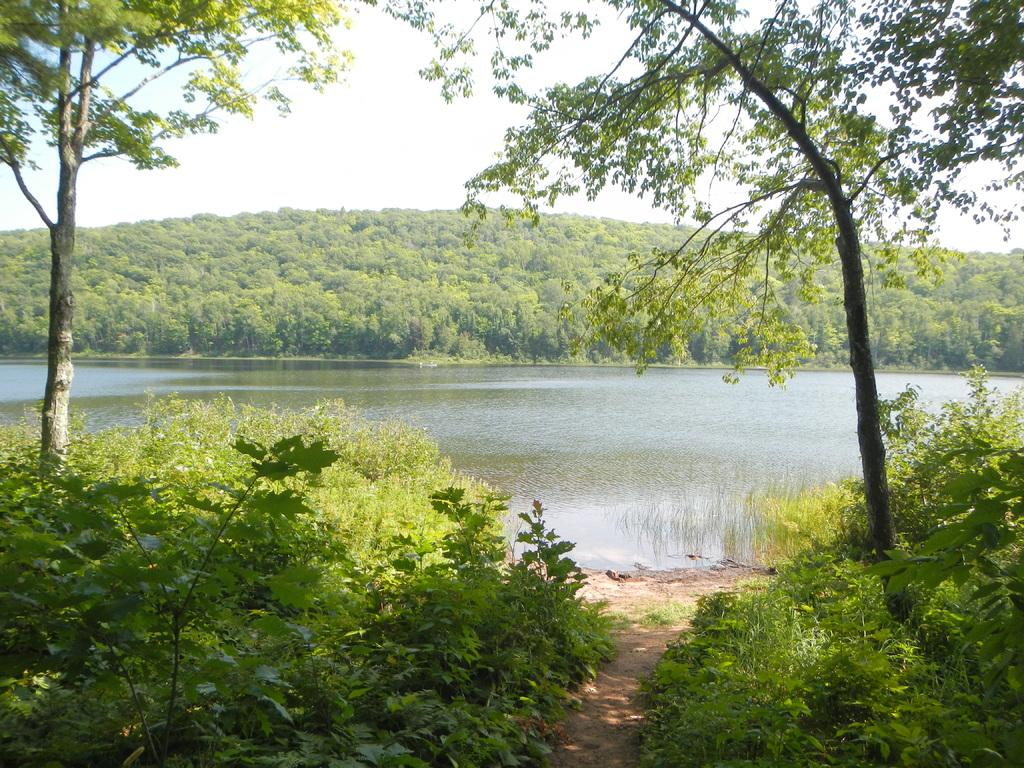What type of vegetation can be seen in the image? There is a group of plants and a group of trees in the image. What type of ground cover is present in the image? There is grass in the image. What natural feature can be seen in the image? There is a water body in the image. What is visible in the background of the image? The sky is visible in the image. What is the condition of the sky in the image? The sky appears to be cloudy in the image. How many fingers can be seen pointing at the thrill in the image? There is no thrill or fingers present in the image. What type of finger can be seen growing on the plants in the image? There are no fingers growing on the plants in the image; they are regular plants. 